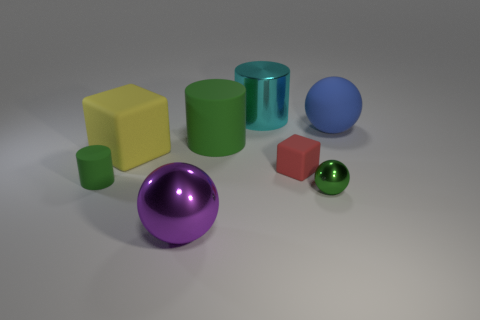What color is the object that is both in front of the tiny matte block and to the right of the large purple thing? The object that sits in front of the small matte block and to the right of the large purple sphere is green. Specifically, it's a green cylinder with a matte finish. 